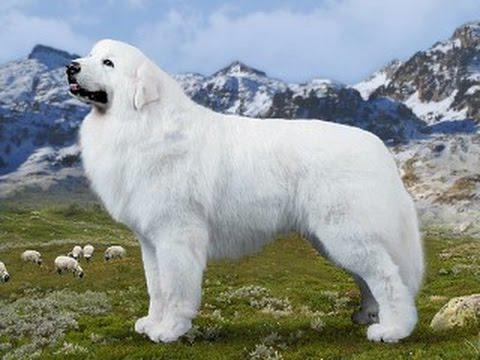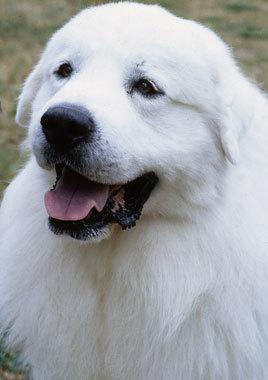The first image is the image on the left, the second image is the image on the right. Evaluate the accuracy of this statement regarding the images: "The right image has two dogs near each other.". Is it true? Answer yes or no. No. 